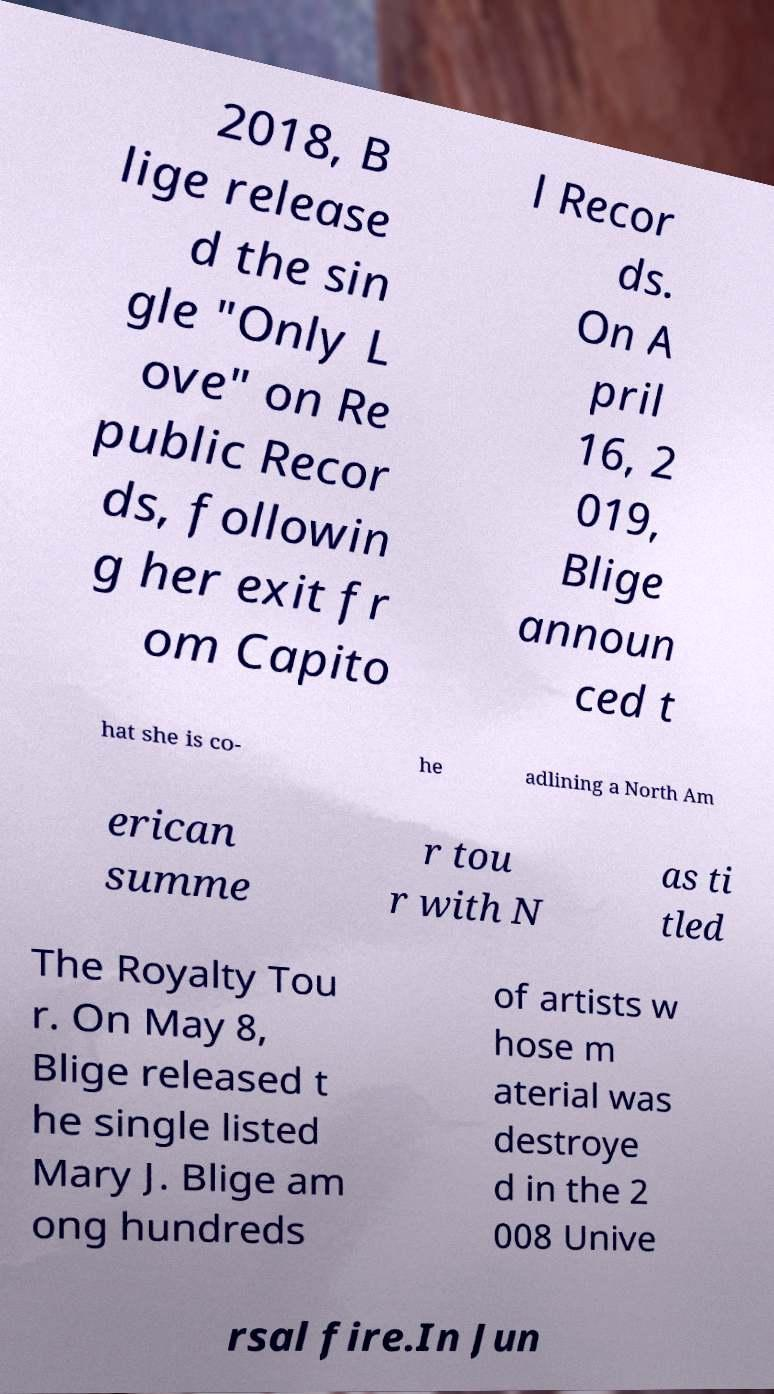Please identify and transcribe the text found in this image. 2018, B lige release d the sin gle "Only L ove" on Re public Recor ds, followin g her exit fr om Capito l Recor ds. On A pril 16, 2 019, Blige announ ced t hat she is co- he adlining a North Am erican summe r tou r with N as ti tled The Royalty Tou r. On May 8, Blige released t he single listed Mary J. Blige am ong hundreds of artists w hose m aterial was destroye d in the 2 008 Unive rsal fire.In Jun 